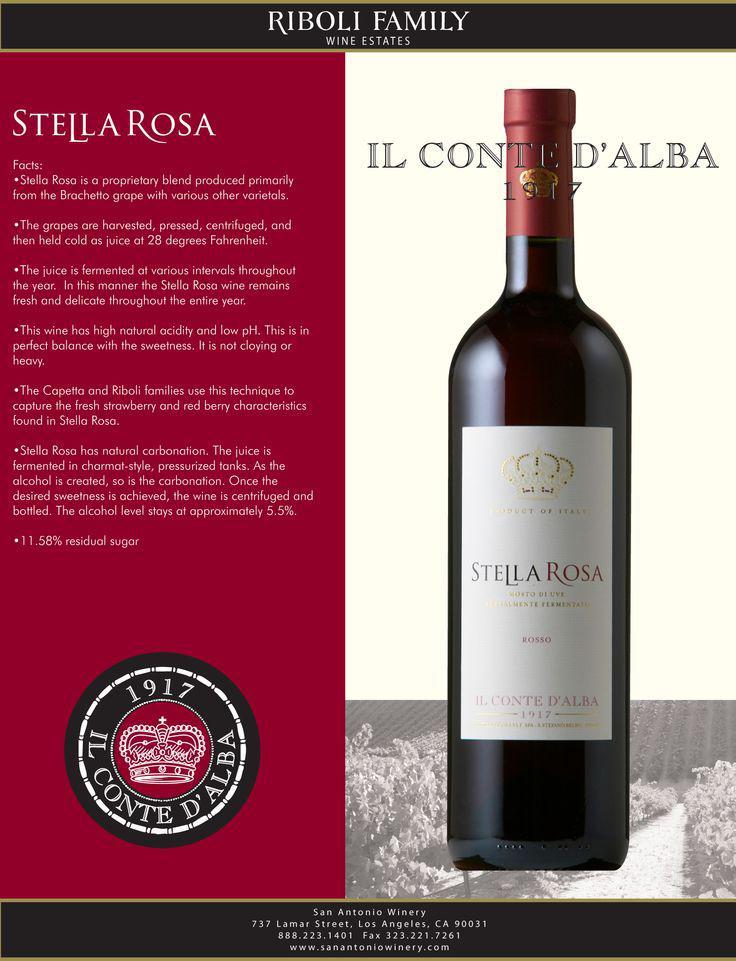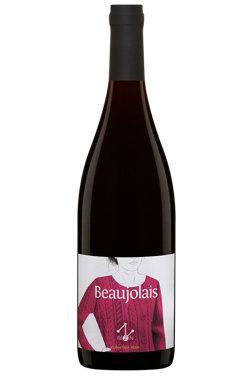The first image is the image on the left, the second image is the image on the right. Assess this claim about the two images: "All bottles are dark with red trim and withthe same long-necked shape.". Correct or not? Answer yes or no. No. 